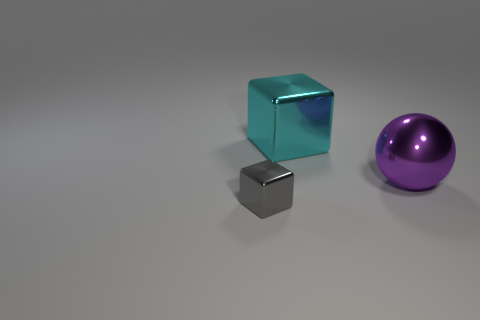Add 2 tiny gray shiny blocks. How many objects exist? 5 Subtract all gray cubes. How many cubes are left? 1 Subtract all balls. How many objects are left? 2 Subtract all blue balls. Subtract all gray cubes. How many balls are left? 1 Subtract all gray metallic things. Subtract all small blocks. How many objects are left? 1 Add 3 small gray metal things. How many small gray metal things are left? 4 Add 2 big cyan matte cubes. How many big cyan matte cubes exist? 2 Subtract 0 yellow cylinders. How many objects are left? 3 